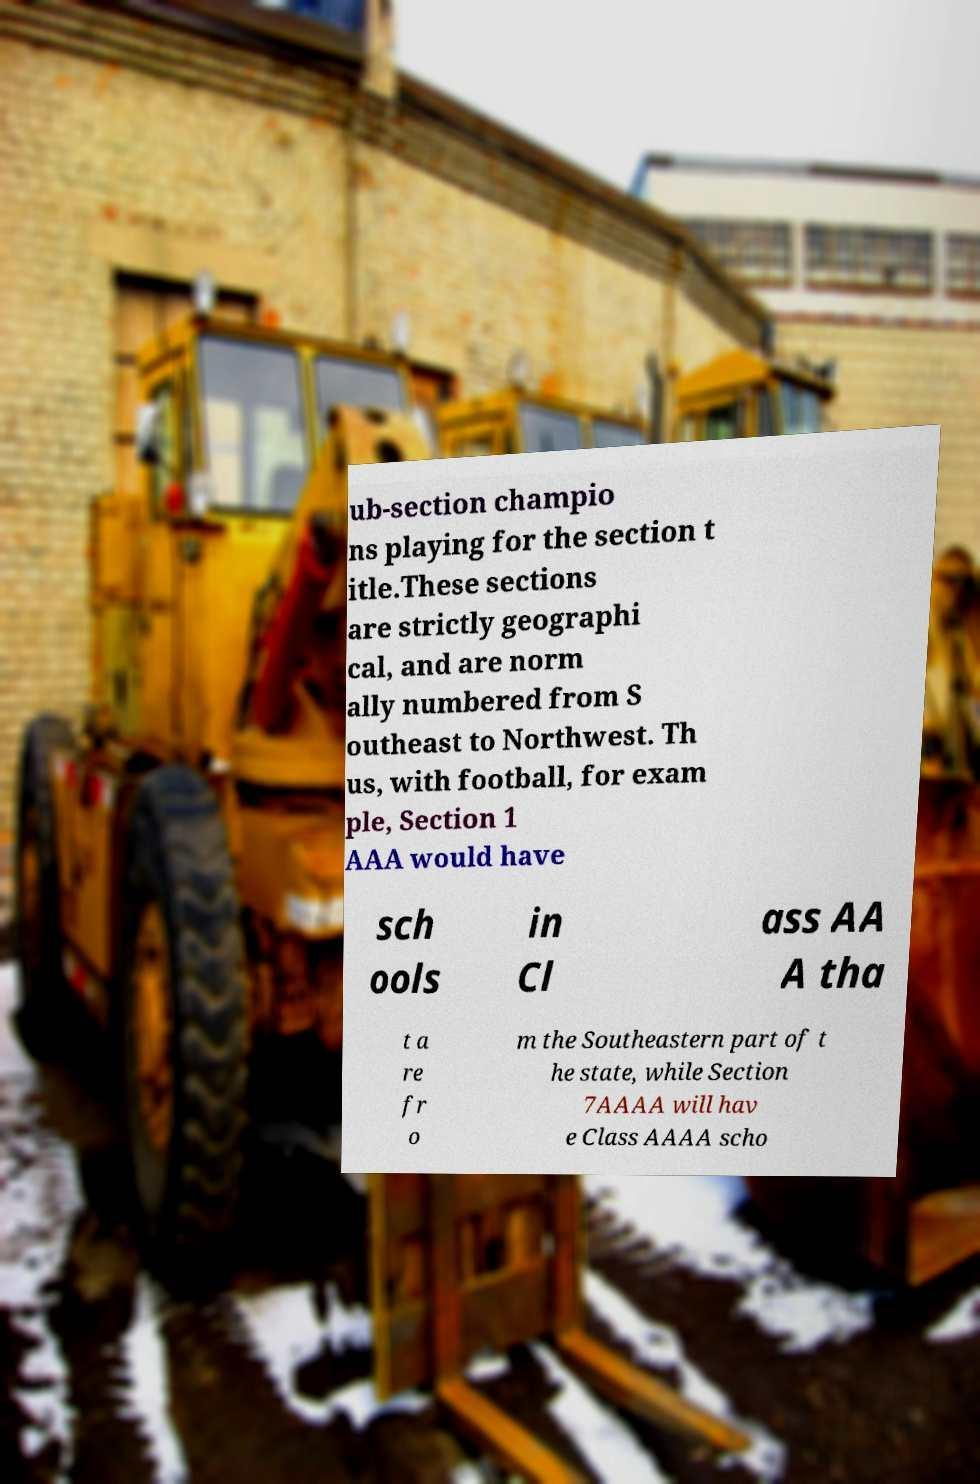Please identify and transcribe the text found in this image. ub-section champio ns playing for the section t itle.These sections are strictly geographi cal, and are norm ally numbered from S outheast to Northwest. Th us, with football, for exam ple, Section 1 AAA would have sch ools in Cl ass AA A tha t a re fr o m the Southeastern part of t he state, while Section 7AAAA will hav e Class AAAA scho 